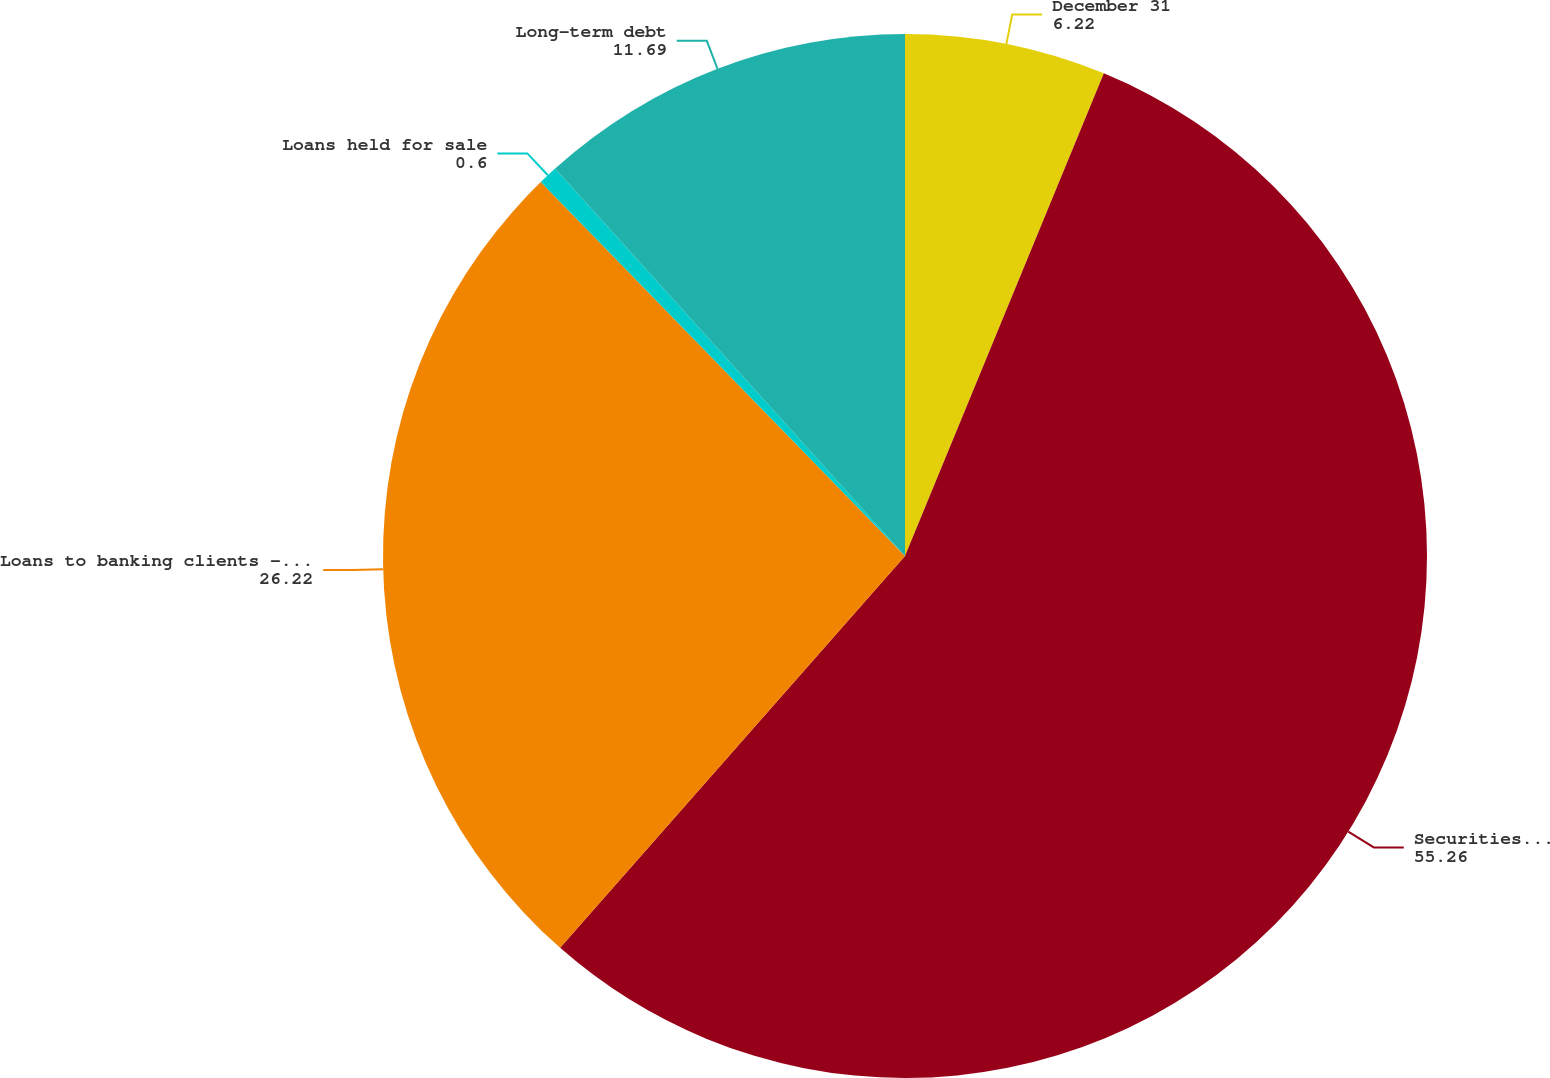Convert chart. <chart><loc_0><loc_0><loc_500><loc_500><pie_chart><fcel>December 31<fcel>Securities held to maturity<fcel>Loans to banking clients - net<fcel>Loans held for sale<fcel>Long-term debt<nl><fcel>6.22%<fcel>55.26%<fcel>26.22%<fcel>0.6%<fcel>11.69%<nl></chart> 